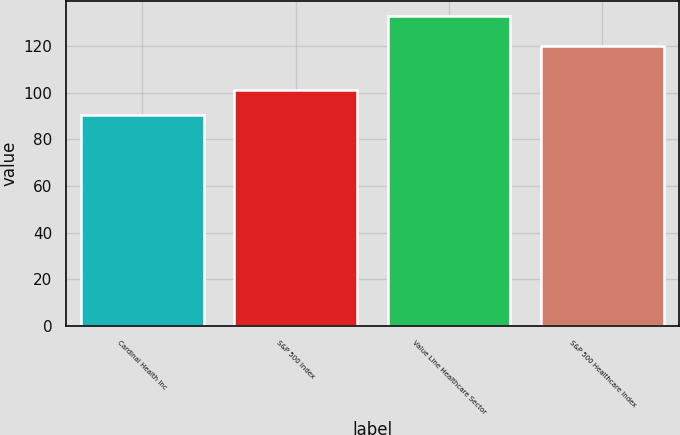Convert chart. <chart><loc_0><loc_0><loc_500><loc_500><bar_chart><fcel>Cardinal Health Inc<fcel>S&P 500 Index<fcel>Value Line Healthcare Sector<fcel>S&P 500 Healthcare Index<nl><fcel>90.62<fcel>101.1<fcel>132.73<fcel>120.17<nl></chart> 